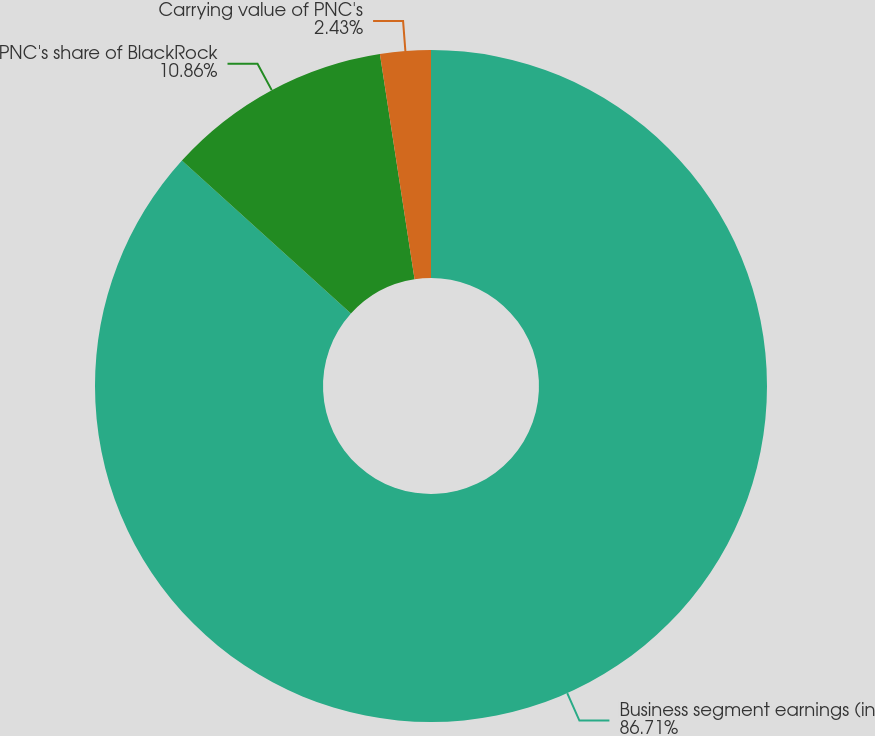<chart> <loc_0><loc_0><loc_500><loc_500><pie_chart><fcel>Business segment earnings (in<fcel>PNC's share of BlackRock<fcel>Carrying value of PNC's<nl><fcel>86.71%<fcel>10.86%<fcel>2.43%<nl></chart> 